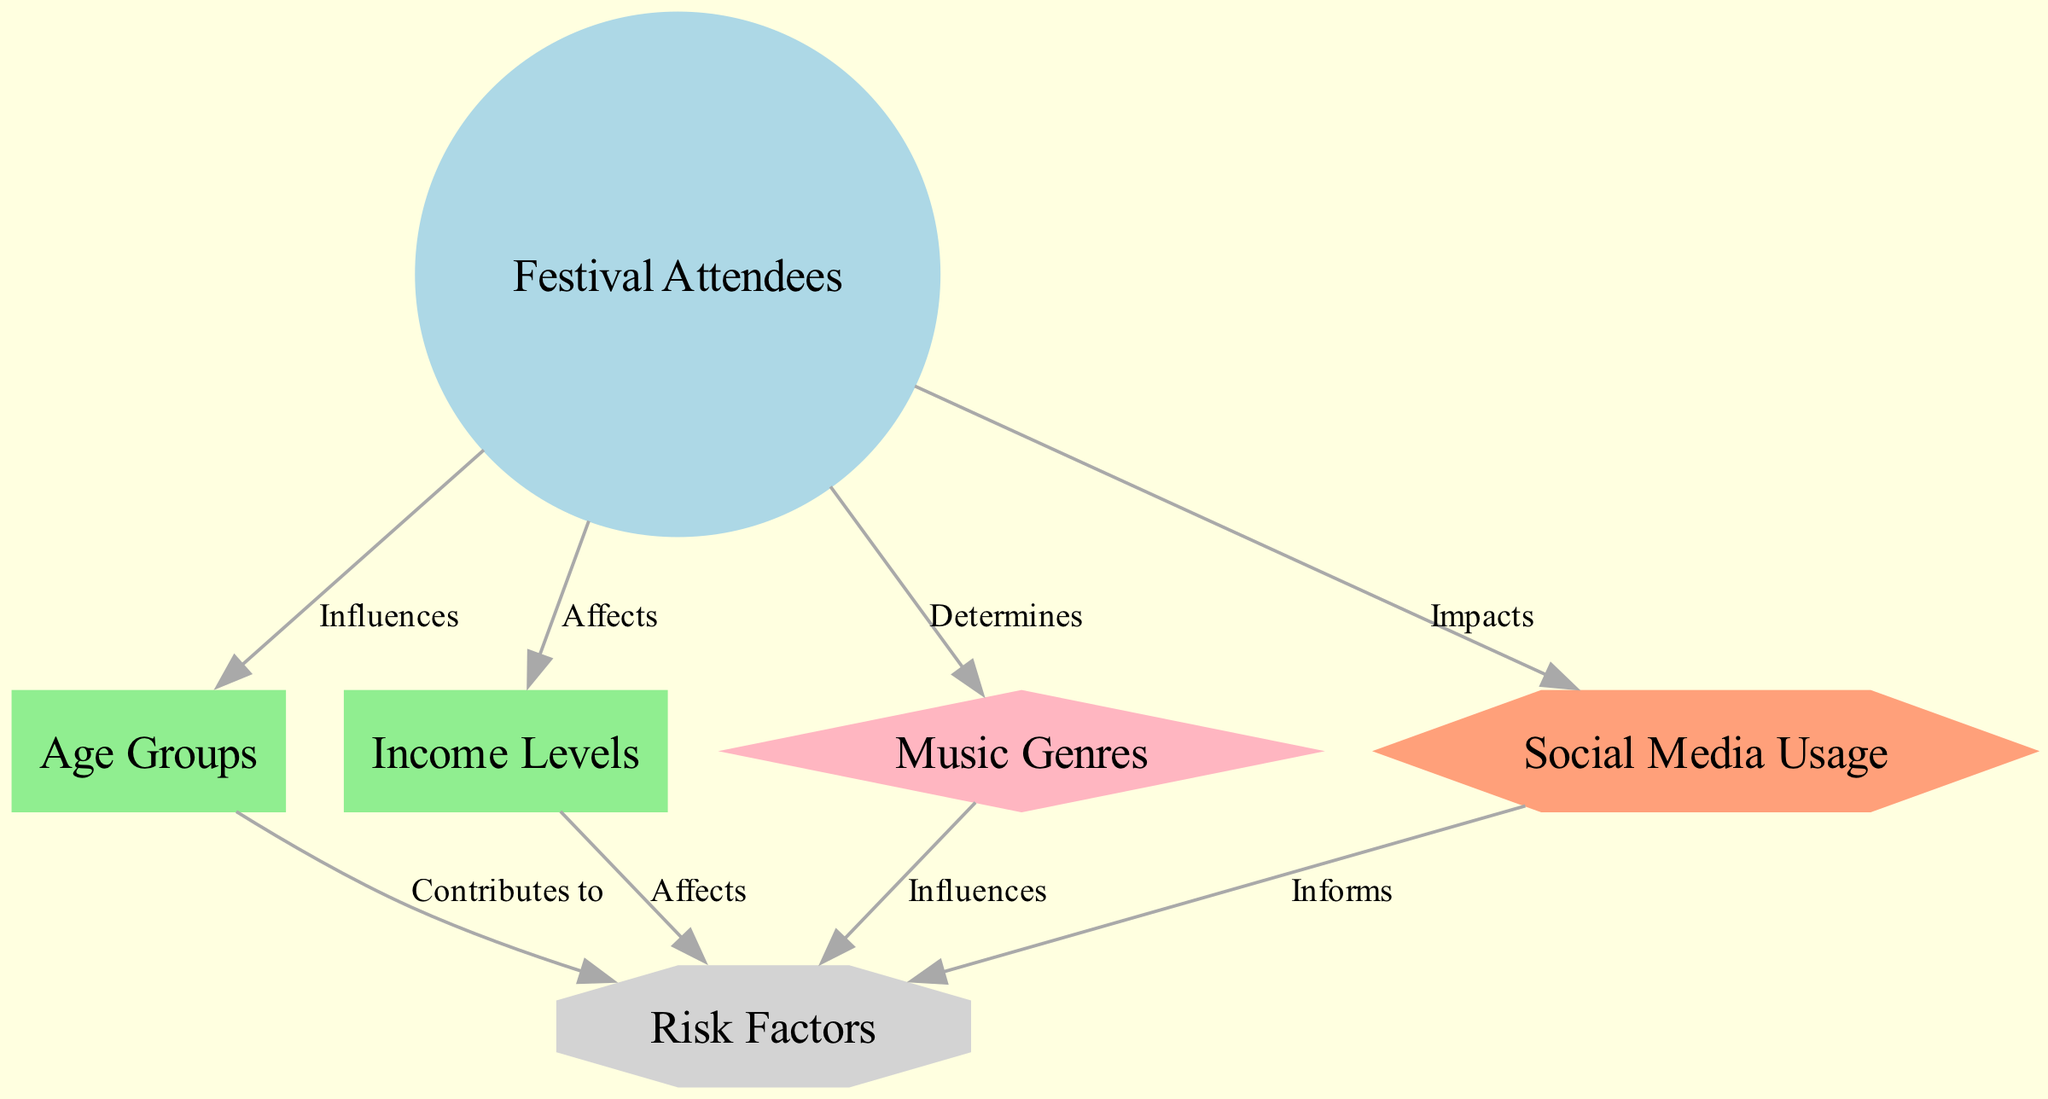What is the central node in the diagram? The central node in the diagram is "Festival Attendees," which represents the main focus of the analysis. It is highlighted as the primary subject connecting various demographic, preference, behavior, and analysis aspects.
Answer: Festival Attendees How many demographic nodes are there? There are two demographic nodes: "Age Groups" and "Income Levels." These nodes represent essential demographic characteristics of the festival attendees and contribute to understanding their risk factors.
Answer: 2 What is the relationship between "Music Genres" and "Risk Factors"? The relationship is defined by the label "Influences," indicating that the preferences regarding music genres can affect the identified risk factors related to festival attendees. This establishes a connection suggesting that genre preferences may play a crucial role in risk assessment.
Answer: Influences Which node contributes to risk factors? The node "Age Groups" contributes to risk factors. This means that the age demographics of the festival attendees have implications on the potential risks that may need to be considered when planning.
Answer: Age Groups What nodes are connected to "Social Media Usage"? "Social Media Usage" is connected to "Risk Factors" with the label "Informs." This indicates that the behaviors associated with social media usage provide insights into the risk factors relevant to festival planning and management.
Answer: Risk Factors How does "Income Levels" affect risk factors? "Income Levels" affects risk factors, suggesting that the economic status of attendees may have implications for their safety and risk exposure at the festival, and it is essential to consider these aspects when analyzing overall risks.
Answer: Affects Which type of node is "Social Media Usage"? The type of node "Social Media Usage" is classified as "Behavior." This indicates that it pertains to the actions and habits of festival attendees regarding their use of social media, which can play a role in shaping risk factors and overall festival dynamics.
Answer: Behavior How many edges are there in the diagram? There are eight edges in the diagram, which represent the various connections and relationships between the nodes, detailing how different aspects influence or determine risk factors the festival planners should consider.
Answer: 8 What node determines the preferences of festival attendees? The node that determines the preferences of festival attendees is "Music Genres," as this node outlines the specific types of music that may appeal to different demographics and affects risk perceptions accordingly.
Answer: Music Genres 